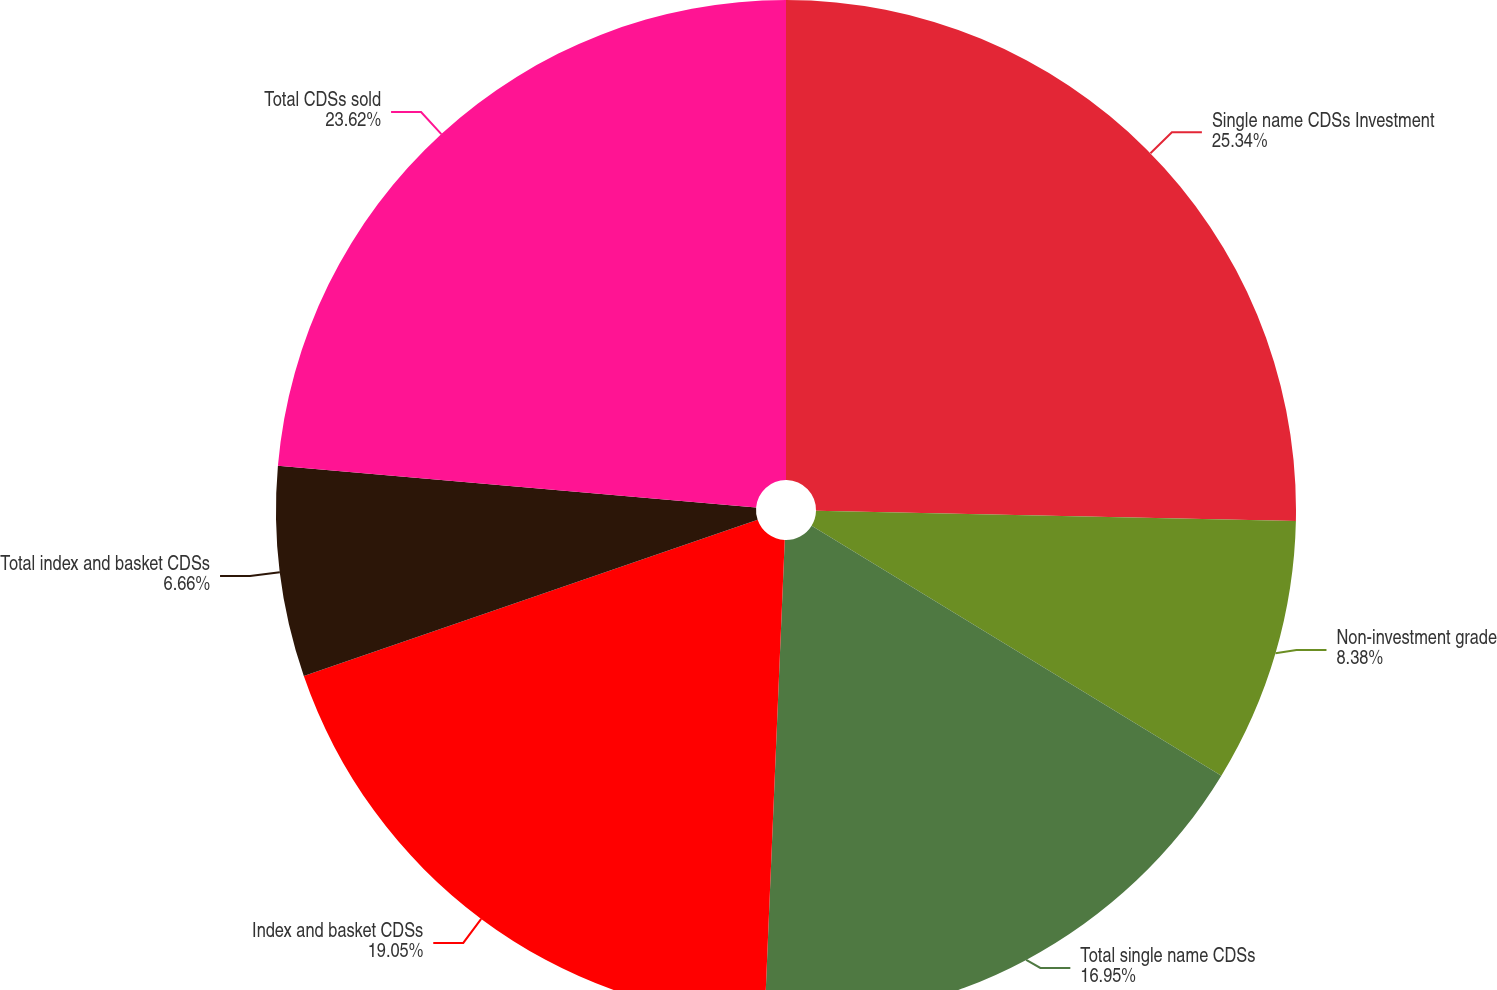<chart> <loc_0><loc_0><loc_500><loc_500><pie_chart><fcel>Single name CDSs Investment<fcel>Non-investment grade<fcel>Total single name CDSs<fcel>Index and basket CDSs<fcel>Total index and basket CDSs<fcel>Total CDSs sold<nl><fcel>25.34%<fcel>8.38%<fcel>16.95%<fcel>19.05%<fcel>6.66%<fcel>23.62%<nl></chart> 